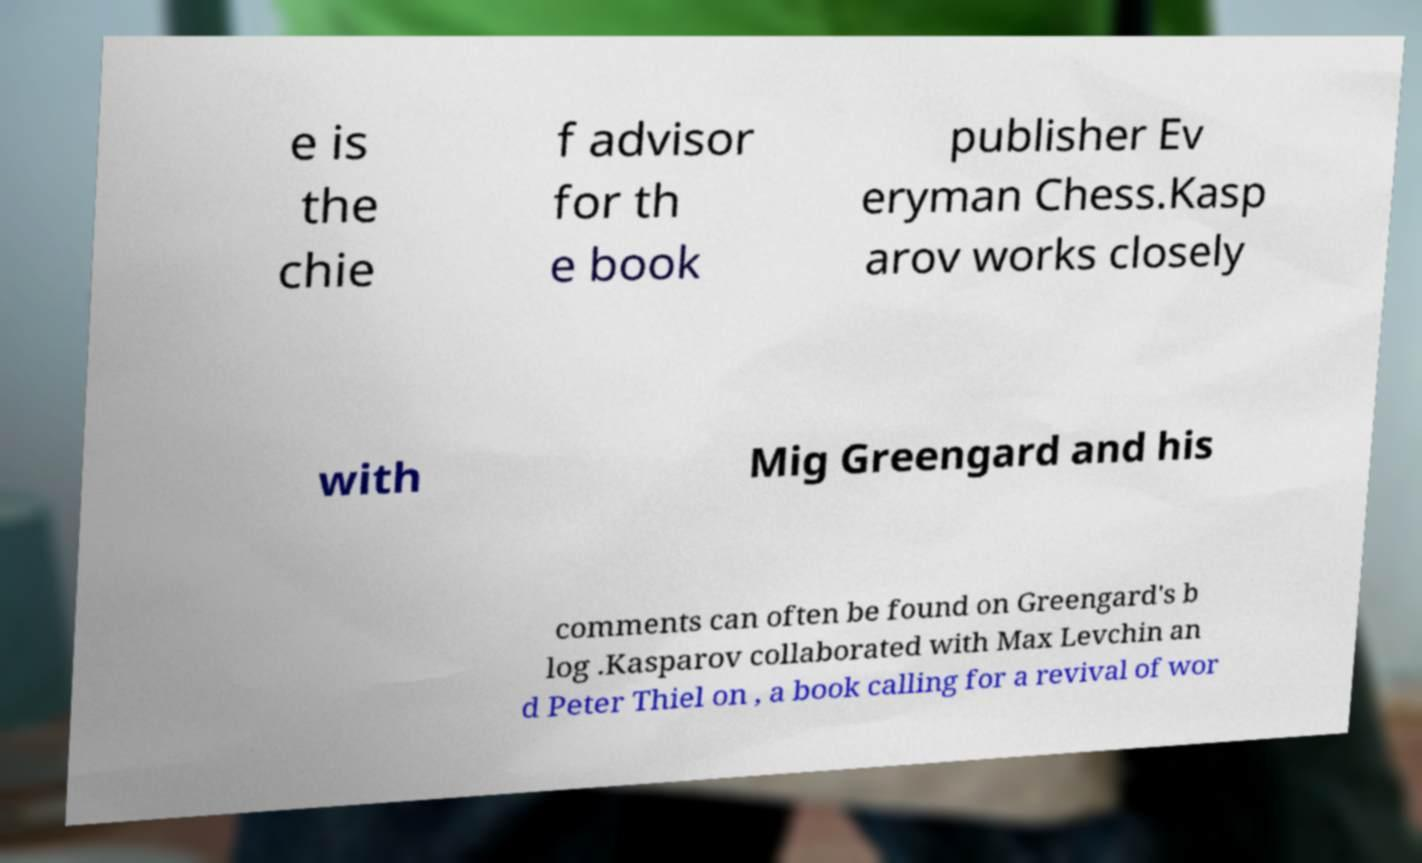Please identify and transcribe the text found in this image. e is the chie f advisor for th e book publisher Ev eryman Chess.Kasp arov works closely with Mig Greengard and his comments can often be found on Greengard's b log .Kasparov collaborated with Max Levchin an d Peter Thiel on , a book calling for a revival of wor 